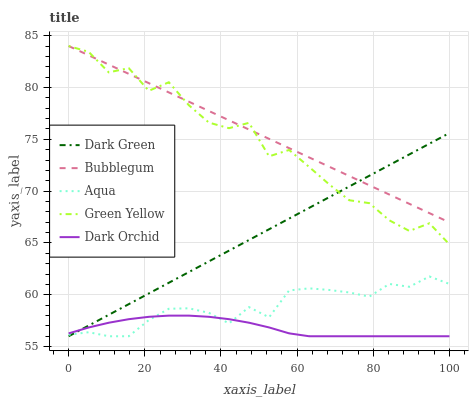Does Dark Orchid have the minimum area under the curve?
Answer yes or no. Yes. Does Bubblegum have the maximum area under the curve?
Answer yes or no. Yes. Does Aqua have the minimum area under the curve?
Answer yes or no. No. Does Aqua have the maximum area under the curve?
Answer yes or no. No. Is Dark Green the smoothest?
Answer yes or no. Yes. Is Green Yellow the roughest?
Answer yes or no. Yes. Is Aqua the smoothest?
Answer yes or no. No. Is Aqua the roughest?
Answer yes or no. No. Does Aqua have the lowest value?
Answer yes or no. Yes. Does Bubblegum have the lowest value?
Answer yes or no. No. Does Bubblegum have the highest value?
Answer yes or no. Yes. Does Aqua have the highest value?
Answer yes or no. No. Is Dark Orchid less than Bubblegum?
Answer yes or no. Yes. Is Green Yellow greater than Aqua?
Answer yes or no. Yes. Does Dark Green intersect Green Yellow?
Answer yes or no. Yes. Is Dark Green less than Green Yellow?
Answer yes or no. No. Is Dark Green greater than Green Yellow?
Answer yes or no. No. Does Dark Orchid intersect Bubblegum?
Answer yes or no. No. 